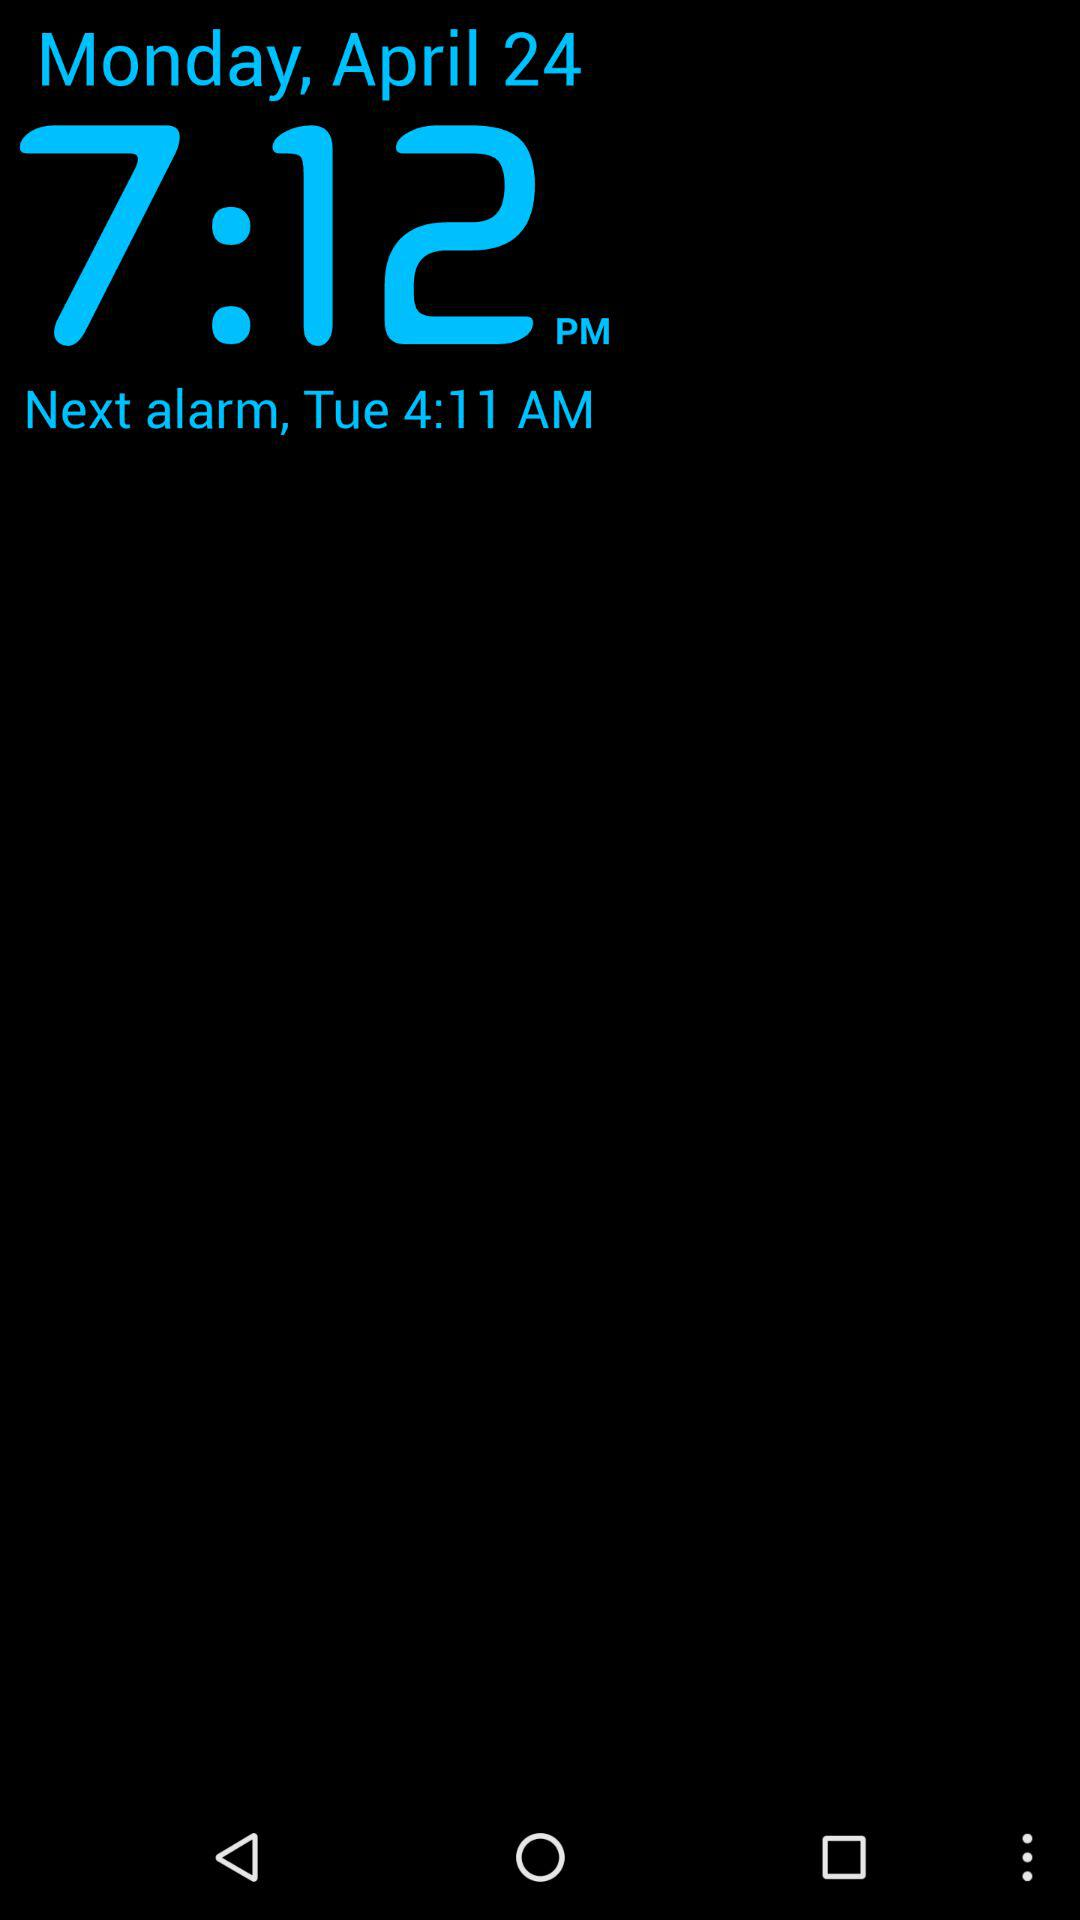What is the current alarm date? The current alarm date is Monday, April 24. 